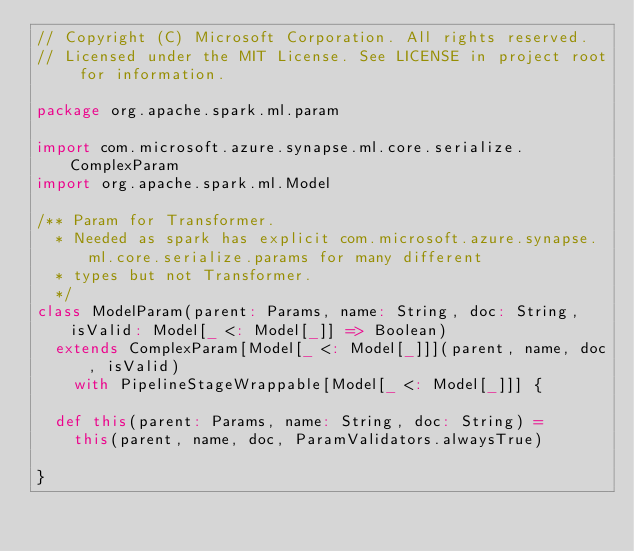Convert code to text. <code><loc_0><loc_0><loc_500><loc_500><_Scala_>// Copyright (C) Microsoft Corporation. All rights reserved.
// Licensed under the MIT License. See LICENSE in project root for information.

package org.apache.spark.ml.param

import com.microsoft.azure.synapse.ml.core.serialize.ComplexParam
import org.apache.spark.ml.Model

/** Param for Transformer.
  * Needed as spark has explicit com.microsoft.azure.synapse.ml.core.serialize.params for many different
  * types but not Transformer.
  */
class ModelParam(parent: Params, name: String, doc: String, isValid: Model[_ <: Model[_]] => Boolean)
  extends ComplexParam[Model[_ <: Model[_]]](parent, name, doc, isValid)
    with PipelineStageWrappable[Model[_ <: Model[_]]] {

  def this(parent: Params, name: String, doc: String) =
    this(parent, name, doc, ParamValidators.alwaysTrue)

}
</code> 